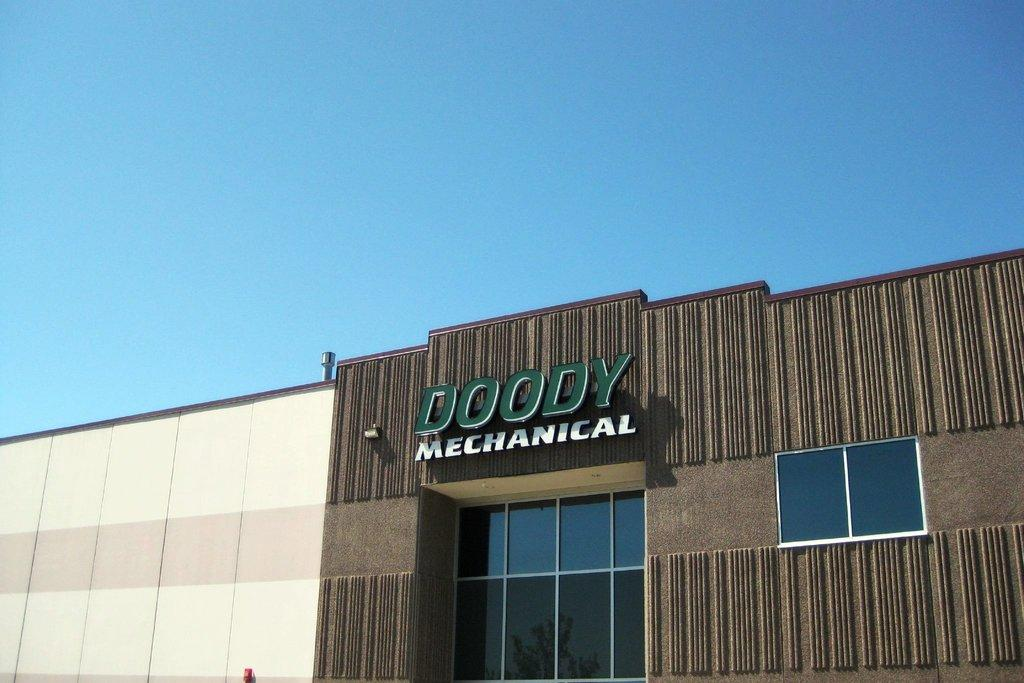What type of structure is present in the image? There is a building in the image. What colors can be seen on the building? The building is cream and brown in color. What is written on the wall of the building? There is text written on the wall of the building. What is visible at the top of the image? The sky is visible at the top of the image. Can you tell me how many babies are crawling on the roof of the building in the image? There are no babies present in the image, and the roof of the building is not visible. 